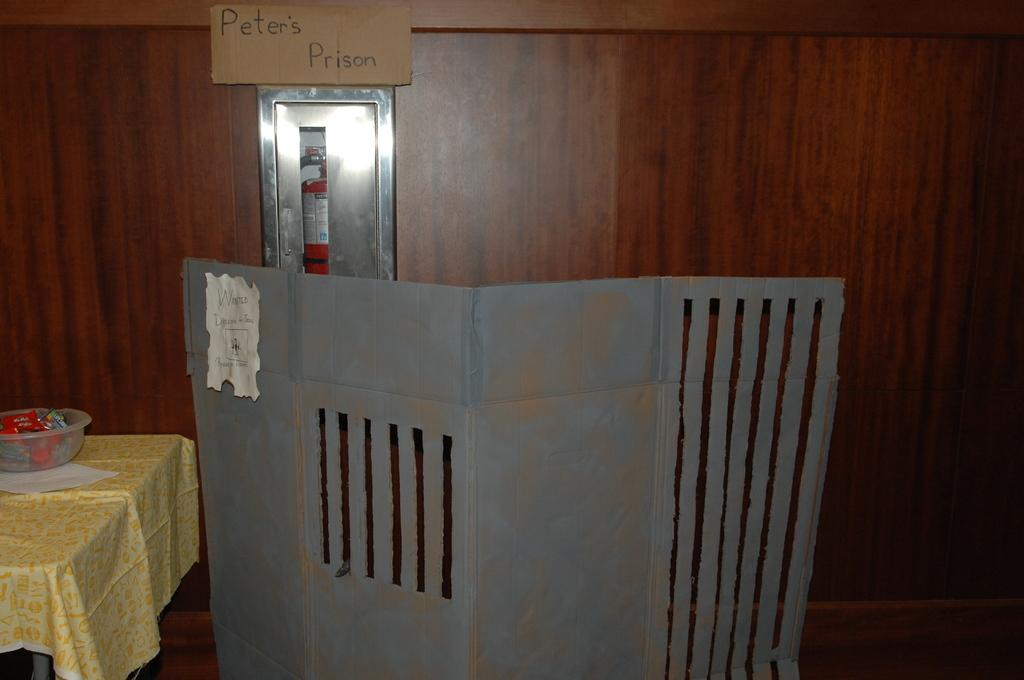<image>
Summarize the visual content of the image. A candy bowl sits by the entrance to Peter's Prison. 